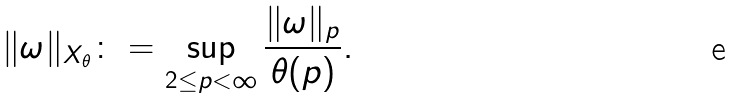<formula> <loc_0><loc_0><loc_500><loc_500>\| \omega \| _ { X _ { \theta } } \colon = \sup _ { 2 \leq p < \infty } \frac { \| \omega \| _ { p } } { \theta ( p ) } .</formula> 